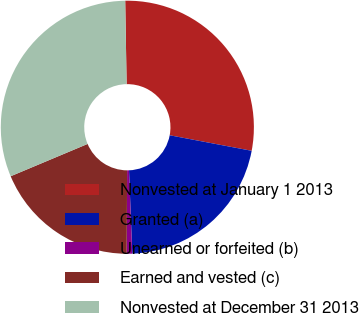<chart> <loc_0><loc_0><loc_500><loc_500><pie_chart><fcel>Nonvested at January 1 2013<fcel>Granted (a)<fcel>Unearned or forfeited (b)<fcel>Earned and vested (c)<fcel>Nonvested at December 31 2013<nl><fcel>28.25%<fcel>21.4%<fcel>0.7%<fcel>18.59%<fcel>31.06%<nl></chart> 